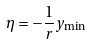<formula> <loc_0><loc_0><loc_500><loc_500>\eta = - \frac { 1 } { r } y _ { \min }</formula> 